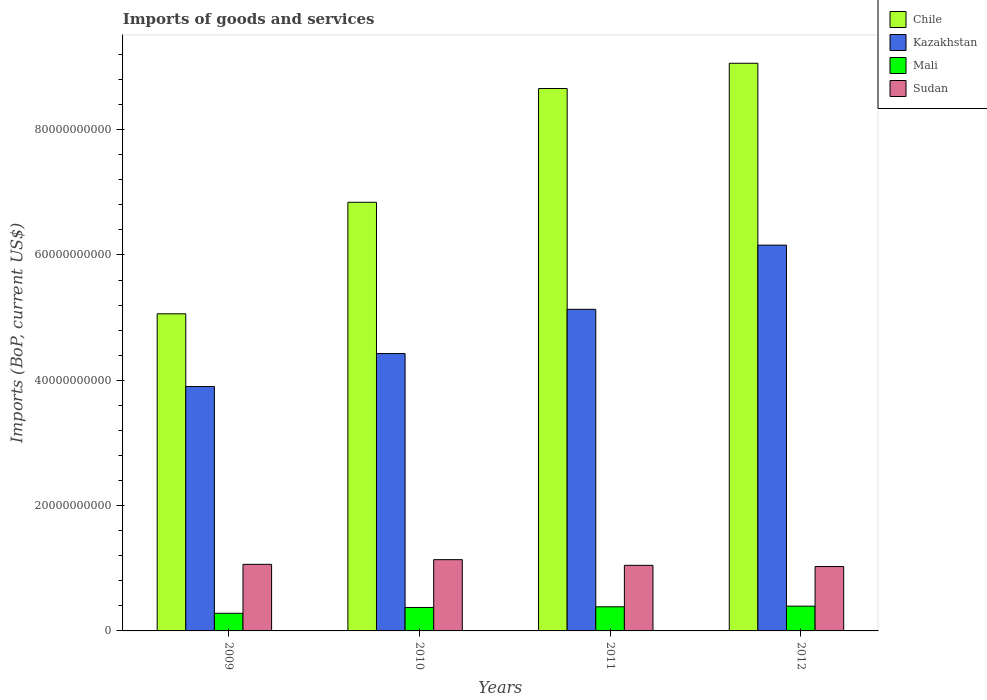How many different coloured bars are there?
Your answer should be very brief. 4. Are the number of bars on each tick of the X-axis equal?
Make the answer very short. Yes. What is the label of the 1st group of bars from the left?
Ensure brevity in your answer.  2009. In how many cases, is the number of bars for a given year not equal to the number of legend labels?
Your response must be concise. 0. What is the amount spent on imports in Chile in 2011?
Ensure brevity in your answer.  8.66e+1. Across all years, what is the maximum amount spent on imports in Mali?
Keep it short and to the point. 3.95e+09. Across all years, what is the minimum amount spent on imports in Kazakhstan?
Keep it short and to the point. 3.90e+1. In which year was the amount spent on imports in Kazakhstan maximum?
Your response must be concise. 2012. In which year was the amount spent on imports in Chile minimum?
Your answer should be very brief. 2009. What is the total amount spent on imports in Kazakhstan in the graph?
Ensure brevity in your answer.  1.96e+11. What is the difference between the amount spent on imports in Chile in 2010 and that in 2012?
Offer a terse response. -2.22e+1. What is the difference between the amount spent on imports in Sudan in 2011 and the amount spent on imports in Mali in 2009?
Keep it short and to the point. 7.65e+09. What is the average amount spent on imports in Kazakhstan per year?
Keep it short and to the point. 4.90e+1. In the year 2009, what is the difference between the amount spent on imports in Mali and amount spent on imports in Sudan?
Provide a short and direct response. -7.82e+09. What is the ratio of the amount spent on imports in Sudan in 2009 to that in 2011?
Offer a very short reply. 1.02. Is the amount spent on imports in Mali in 2010 less than that in 2012?
Provide a short and direct response. Yes. What is the difference between the highest and the second highest amount spent on imports in Chile?
Make the answer very short. 4.03e+09. What is the difference between the highest and the lowest amount spent on imports in Sudan?
Give a very brief answer. 1.10e+09. Is it the case that in every year, the sum of the amount spent on imports in Chile and amount spent on imports in Kazakhstan is greater than the sum of amount spent on imports in Sudan and amount spent on imports in Mali?
Provide a succinct answer. Yes. What does the 2nd bar from the right in 2010 represents?
Offer a terse response. Mali. How many bars are there?
Keep it short and to the point. 16. Are the values on the major ticks of Y-axis written in scientific E-notation?
Your response must be concise. No. Where does the legend appear in the graph?
Offer a terse response. Top right. What is the title of the graph?
Offer a very short reply. Imports of goods and services. Does "China" appear as one of the legend labels in the graph?
Make the answer very short. No. What is the label or title of the Y-axis?
Keep it short and to the point. Imports (BoP, current US$). What is the Imports (BoP, current US$) in Chile in 2009?
Give a very brief answer. 5.06e+1. What is the Imports (BoP, current US$) of Kazakhstan in 2009?
Provide a short and direct response. 3.90e+1. What is the Imports (BoP, current US$) of Mali in 2009?
Give a very brief answer. 2.81e+09. What is the Imports (BoP, current US$) of Sudan in 2009?
Your response must be concise. 1.06e+1. What is the Imports (BoP, current US$) in Chile in 2010?
Your answer should be very brief. 6.84e+1. What is the Imports (BoP, current US$) in Kazakhstan in 2010?
Your response must be concise. 4.43e+1. What is the Imports (BoP, current US$) of Mali in 2010?
Make the answer very short. 3.74e+09. What is the Imports (BoP, current US$) in Sudan in 2010?
Provide a succinct answer. 1.14e+1. What is the Imports (BoP, current US$) of Chile in 2011?
Your response must be concise. 8.66e+1. What is the Imports (BoP, current US$) of Kazakhstan in 2011?
Keep it short and to the point. 5.13e+1. What is the Imports (BoP, current US$) in Mali in 2011?
Keep it short and to the point. 3.85e+09. What is the Imports (BoP, current US$) of Sudan in 2011?
Your answer should be compact. 1.05e+1. What is the Imports (BoP, current US$) in Chile in 2012?
Offer a terse response. 9.06e+1. What is the Imports (BoP, current US$) of Kazakhstan in 2012?
Your response must be concise. 6.16e+1. What is the Imports (BoP, current US$) of Mali in 2012?
Give a very brief answer. 3.95e+09. What is the Imports (BoP, current US$) in Sudan in 2012?
Ensure brevity in your answer.  1.03e+1. Across all years, what is the maximum Imports (BoP, current US$) of Chile?
Give a very brief answer. 9.06e+1. Across all years, what is the maximum Imports (BoP, current US$) in Kazakhstan?
Offer a very short reply. 6.16e+1. Across all years, what is the maximum Imports (BoP, current US$) in Mali?
Provide a short and direct response. 3.95e+09. Across all years, what is the maximum Imports (BoP, current US$) in Sudan?
Make the answer very short. 1.14e+1. Across all years, what is the minimum Imports (BoP, current US$) of Chile?
Make the answer very short. 5.06e+1. Across all years, what is the minimum Imports (BoP, current US$) of Kazakhstan?
Make the answer very short. 3.90e+1. Across all years, what is the minimum Imports (BoP, current US$) in Mali?
Your answer should be compact. 2.81e+09. Across all years, what is the minimum Imports (BoP, current US$) of Sudan?
Your answer should be very brief. 1.03e+1. What is the total Imports (BoP, current US$) of Chile in the graph?
Ensure brevity in your answer.  2.96e+11. What is the total Imports (BoP, current US$) of Kazakhstan in the graph?
Your answer should be very brief. 1.96e+11. What is the total Imports (BoP, current US$) of Mali in the graph?
Offer a very short reply. 1.44e+1. What is the total Imports (BoP, current US$) in Sudan in the graph?
Give a very brief answer. 4.27e+1. What is the difference between the Imports (BoP, current US$) in Chile in 2009 and that in 2010?
Provide a succinct answer. -1.78e+1. What is the difference between the Imports (BoP, current US$) in Kazakhstan in 2009 and that in 2010?
Your answer should be very brief. -5.26e+09. What is the difference between the Imports (BoP, current US$) in Mali in 2009 and that in 2010?
Your answer should be very brief. -9.33e+08. What is the difference between the Imports (BoP, current US$) in Sudan in 2009 and that in 2010?
Offer a terse response. -7.43e+08. What is the difference between the Imports (BoP, current US$) in Chile in 2009 and that in 2011?
Offer a terse response. -3.60e+1. What is the difference between the Imports (BoP, current US$) in Kazakhstan in 2009 and that in 2011?
Offer a terse response. -1.23e+1. What is the difference between the Imports (BoP, current US$) of Mali in 2009 and that in 2011?
Make the answer very short. -1.04e+09. What is the difference between the Imports (BoP, current US$) in Sudan in 2009 and that in 2011?
Provide a succinct answer. 1.64e+08. What is the difference between the Imports (BoP, current US$) in Chile in 2009 and that in 2012?
Provide a succinct answer. -4.00e+1. What is the difference between the Imports (BoP, current US$) in Kazakhstan in 2009 and that in 2012?
Offer a terse response. -2.26e+1. What is the difference between the Imports (BoP, current US$) in Mali in 2009 and that in 2012?
Provide a succinct answer. -1.14e+09. What is the difference between the Imports (BoP, current US$) in Sudan in 2009 and that in 2012?
Make the answer very short. 3.55e+08. What is the difference between the Imports (BoP, current US$) of Chile in 2010 and that in 2011?
Your response must be concise. -1.82e+1. What is the difference between the Imports (BoP, current US$) of Kazakhstan in 2010 and that in 2011?
Provide a short and direct response. -7.06e+09. What is the difference between the Imports (BoP, current US$) of Mali in 2010 and that in 2011?
Keep it short and to the point. -1.06e+08. What is the difference between the Imports (BoP, current US$) in Sudan in 2010 and that in 2011?
Keep it short and to the point. 9.07e+08. What is the difference between the Imports (BoP, current US$) in Chile in 2010 and that in 2012?
Offer a very short reply. -2.22e+1. What is the difference between the Imports (BoP, current US$) in Kazakhstan in 2010 and that in 2012?
Provide a succinct answer. -1.73e+1. What is the difference between the Imports (BoP, current US$) of Mali in 2010 and that in 2012?
Offer a terse response. -2.09e+08. What is the difference between the Imports (BoP, current US$) of Sudan in 2010 and that in 2012?
Keep it short and to the point. 1.10e+09. What is the difference between the Imports (BoP, current US$) of Chile in 2011 and that in 2012?
Give a very brief answer. -4.03e+09. What is the difference between the Imports (BoP, current US$) in Kazakhstan in 2011 and that in 2012?
Make the answer very short. -1.02e+1. What is the difference between the Imports (BoP, current US$) of Mali in 2011 and that in 2012?
Keep it short and to the point. -1.03e+08. What is the difference between the Imports (BoP, current US$) of Sudan in 2011 and that in 2012?
Provide a succinct answer. 1.92e+08. What is the difference between the Imports (BoP, current US$) in Chile in 2009 and the Imports (BoP, current US$) in Kazakhstan in 2010?
Provide a short and direct response. 6.35e+09. What is the difference between the Imports (BoP, current US$) in Chile in 2009 and the Imports (BoP, current US$) in Mali in 2010?
Your answer should be compact. 4.69e+1. What is the difference between the Imports (BoP, current US$) of Chile in 2009 and the Imports (BoP, current US$) of Sudan in 2010?
Keep it short and to the point. 3.92e+1. What is the difference between the Imports (BoP, current US$) in Kazakhstan in 2009 and the Imports (BoP, current US$) in Mali in 2010?
Make the answer very short. 3.53e+1. What is the difference between the Imports (BoP, current US$) of Kazakhstan in 2009 and the Imports (BoP, current US$) of Sudan in 2010?
Your answer should be compact. 2.76e+1. What is the difference between the Imports (BoP, current US$) in Mali in 2009 and the Imports (BoP, current US$) in Sudan in 2010?
Offer a terse response. -8.56e+09. What is the difference between the Imports (BoP, current US$) in Chile in 2009 and the Imports (BoP, current US$) in Kazakhstan in 2011?
Keep it short and to the point. -7.17e+08. What is the difference between the Imports (BoP, current US$) of Chile in 2009 and the Imports (BoP, current US$) of Mali in 2011?
Keep it short and to the point. 4.68e+1. What is the difference between the Imports (BoP, current US$) in Chile in 2009 and the Imports (BoP, current US$) in Sudan in 2011?
Your response must be concise. 4.01e+1. What is the difference between the Imports (BoP, current US$) of Kazakhstan in 2009 and the Imports (BoP, current US$) of Mali in 2011?
Provide a short and direct response. 3.52e+1. What is the difference between the Imports (BoP, current US$) in Kazakhstan in 2009 and the Imports (BoP, current US$) in Sudan in 2011?
Make the answer very short. 2.85e+1. What is the difference between the Imports (BoP, current US$) in Mali in 2009 and the Imports (BoP, current US$) in Sudan in 2011?
Make the answer very short. -7.65e+09. What is the difference between the Imports (BoP, current US$) in Chile in 2009 and the Imports (BoP, current US$) in Kazakhstan in 2012?
Make the answer very short. -1.10e+1. What is the difference between the Imports (BoP, current US$) in Chile in 2009 and the Imports (BoP, current US$) in Mali in 2012?
Provide a short and direct response. 4.67e+1. What is the difference between the Imports (BoP, current US$) of Chile in 2009 and the Imports (BoP, current US$) of Sudan in 2012?
Give a very brief answer. 4.03e+1. What is the difference between the Imports (BoP, current US$) in Kazakhstan in 2009 and the Imports (BoP, current US$) in Mali in 2012?
Offer a terse response. 3.50e+1. What is the difference between the Imports (BoP, current US$) of Kazakhstan in 2009 and the Imports (BoP, current US$) of Sudan in 2012?
Keep it short and to the point. 2.87e+1. What is the difference between the Imports (BoP, current US$) in Mali in 2009 and the Imports (BoP, current US$) in Sudan in 2012?
Your answer should be very brief. -7.46e+09. What is the difference between the Imports (BoP, current US$) of Chile in 2010 and the Imports (BoP, current US$) of Kazakhstan in 2011?
Provide a short and direct response. 1.71e+1. What is the difference between the Imports (BoP, current US$) of Chile in 2010 and the Imports (BoP, current US$) of Mali in 2011?
Offer a very short reply. 6.45e+1. What is the difference between the Imports (BoP, current US$) of Chile in 2010 and the Imports (BoP, current US$) of Sudan in 2011?
Your answer should be very brief. 5.79e+1. What is the difference between the Imports (BoP, current US$) of Kazakhstan in 2010 and the Imports (BoP, current US$) of Mali in 2011?
Offer a terse response. 4.04e+1. What is the difference between the Imports (BoP, current US$) of Kazakhstan in 2010 and the Imports (BoP, current US$) of Sudan in 2011?
Offer a very short reply. 3.38e+1. What is the difference between the Imports (BoP, current US$) of Mali in 2010 and the Imports (BoP, current US$) of Sudan in 2011?
Provide a short and direct response. -6.72e+09. What is the difference between the Imports (BoP, current US$) of Chile in 2010 and the Imports (BoP, current US$) of Kazakhstan in 2012?
Keep it short and to the point. 6.84e+09. What is the difference between the Imports (BoP, current US$) in Chile in 2010 and the Imports (BoP, current US$) in Mali in 2012?
Provide a succinct answer. 6.44e+1. What is the difference between the Imports (BoP, current US$) of Chile in 2010 and the Imports (BoP, current US$) of Sudan in 2012?
Offer a terse response. 5.81e+1. What is the difference between the Imports (BoP, current US$) of Kazakhstan in 2010 and the Imports (BoP, current US$) of Mali in 2012?
Offer a terse response. 4.03e+1. What is the difference between the Imports (BoP, current US$) of Kazakhstan in 2010 and the Imports (BoP, current US$) of Sudan in 2012?
Make the answer very short. 3.40e+1. What is the difference between the Imports (BoP, current US$) in Mali in 2010 and the Imports (BoP, current US$) in Sudan in 2012?
Offer a terse response. -6.53e+09. What is the difference between the Imports (BoP, current US$) of Chile in 2011 and the Imports (BoP, current US$) of Kazakhstan in 2012?
Provide a short and direct response. 2.50e+1. What is the difference between the Imports (BoP, current US$) in Chile in 2011 and the Imports (BoP, current US$) in Mali in 2012?
Make the answer very short. 8.26e+1. What is the difference between the Imports (BoP, current US$) of Chile in 2011 and the Imports (BoP, current US$) of Sudan in 2012?
Provide a short and direct response. 7.63e+1. What is the difference between the Imports (BoP, current US$) in Kazakhstan in 2011 and the Imports (BoP, current US$) in Mali in 2012?
Offer a terse response. 4.74e+1. What is the difference between the Imports (BoP, current US$) of Kazakhstan in 2011 and the Imports (BoP, current US$) of Sudan in 2012?
Offer a terse response. 4.10e+1. What is the difference between the Imports (BoP, current US$) of Mali in 2011 and the Imports (BoP, current US$) of Sudan in 2012?
Give a very brief answer. -6.42e+09. What is the average Imports (BoP, current US$) in Chile per year?
Offer a very short reply. 7.40e+1. What is the average Imports (BoP, current US$) of Kazakhstan per year?
Offer a very short reply. 4.90e+1. What is the average Imports (BoP, current US$) in Mali per year?
Offer a terse response. 3.59e+09. What is the average Imports (BoP, current US$) of Sudan per year?
Provide a succinct answer. 1.07e+1. In the year 2009, what is the difference between the Imports (BoP, current US$) in Chile and Imports (BoP, current US$) in Kazakhstan?
Your response must be concise. 1.16e+1. In the year 2009, what is the difference between the Imports (BoP, current US$) of Chile and Imports (BoP, current US$) of Mali?
Your answer should be compact. 4.78e+1. In the year 2009, what is the difference between the Imports (BoP, current US$) of Chile and Imports (BoP, current US$) of Sudan?
Keep it short and to the point. 4.00e+1. In the year 2009, what is the difference between the Imports (BoP, current US$) of Kazakhstan and Imports (BoP, current US$) of Mali?
Make the answer very short. 3.62e+1. In the year 2009, what is the difference between the Imports (BoP, current US$) of Kazakhstan and Imports (BoP, current US$) of Sudan?
Keep it short and to the point. 2.84e+1. In the year 2009, what is the difference between the Imports (BoP, current US$) of Mali and Imports (BoP, current US$) of Sudan?
Keep it short and to the point. -7.82e+09. In the year 2010, what is the difference between the Imports (BoP, current US$) in Chile and Imports (BoP, current US$) in Kazakhstan?
Ensure brevity in your answer.  2.41e+1. In the year 2010, what is the difference between the Imports (BoP, current US$) in Chile and Imports (BoP, current US$) in Mali?
Offer a very short reply. 6.47e+1. In the year 2010, what is the difference between the Imports (BoP, current US$) in Chile and Imports (BoP, current US$) in Sudan?
Give a very brief answer. 5.70e+1. In the year 2010, what is the difference between the Imports (BoP, current US$) of Kazakhstan and Imports (BoP, current US$) of Mali?
Your answer should be very brief. 4.05e+1. In the year 2010, what is the difference between the Imports (BoP, current US$) in Kazakhstan and Imports (BoP, current US$) in Sudan?
Your answer should be compact. 3.29e+1. In the year 2010, what is the difference between the Imports (BoP, current US$) in Mali and Imports (BoP, current US$) in Sudan?
Keep it short and to the point. -7.63e+09. In the year 2011, what is the difference between the Imports (BoP, current US$) of Chile and Imports (BoP, current US$) of Kazakhstan?
Offer a very short reply. 3.52e+1. In the year 2011, what is the difference between the Imports (BoP, current US$) in Chile and Imports (BoP, current US$) in Mali?
Keep it short and to the point. 8.27e+1. In the year 2011, what is the difference between the Imports (BoP, current US$) in Chile and Imports (BoP, current US$) in Sudan?
Make the answer very short. 7.61e+1. In the year 2011, what is the difference between the Imports (BoP, current US$) in Kazakhstan and Imports (BoP, current US$) in Mali?
Make the answer very short. 4.75e+1. In the year 2011, what is the difference between the Imports (BoP, current US$) of Kazakhstan and Imports (BoP, current US$) of Sudan?
Provide a succinct answer. 4.09e+1. In the year 2011, what is the difference between the Imports (BoP, current US$) in Mali and Imports (BoP, current US$) in Sudan?
Offer a terse response. -6.61e+09. In the year 2012, what is the difference between the Imports (BoP, current US$) in Chile and Imports (BoP, current US$) in Kazakhstan?
Offer a very short reply. 2.90e+1. In the year 2012, what is the difference between the Imports (BoP, current US$) of Chile and Imports (BoP, current US$) of Mali?
Keep it short and to the point. 8.66e+1. In the year 2012, what is the difference between the Imports (BoP, current US$) of Chile and Imports (BoP, current US$) of Sudan?
Offer a very short reply. 8.03e+1. In the year 2012, what is the difference between the Imports (BoP, current US$) of Kazakhstan and Imports (BoP, current US$) of Mali?
Ensure brevity in your answer.  5.76e+1. In the year 2012, what is the difference between the Imports (BoP, current US$) in Kazakhstan and Imports (BoP, current US$) in Sudan?
Ensure brevity in your answer.  5.13e+1. In the year 2012, what is the difference between the Imports (BoP, current US$) in Mali and Imports (BoP, current US$) in Sudan?
Offer a very short reply. -6.32e+09. What is the ratio of the Imports (BoP, current US$) of Chile in 2009 to that in 2010?
Provide a short and direct response. 0.74. What is the ratio of the Imports (BoP, current US$) in Kazakhstan in 2009 to that in 2010?
Your answer should be compact. 0.88. What is the ratio of the Imports (BoP, current US$) in Mali in 2009 to that in 2010?
Your answer should be compact. 0.75. What is the ratio of the Imports (BoP, current US$) in Sudan in 2009 to that in 2010?
Provide a short and direct response. 0.93. What is the ratio of the Imports (BoP, current US$) in Chile in 2009 to that in 2011?
Ensure brevity in your answer.  0.58. What is the ratio of the Imports (BoP, current US$) in Kazakhstan in 2009 to that in 2011?
Give a very brief answer. 0.76. What is the ratio of the Imports (BoP, current US$) of Mali in 2009 to that in 2011?
Ensure brevity in your answer.  0.73. What is the ratio of the Imports (BoP, current US$) in Sudan in 2009 to that in 2011?
Ensure brevity in your answer.  1.02. What is the ratio of the Imports (BoP, current US$) in Chile in 2009 to that in 2012?
Your response must be concise. 0.56. What is the ratio of the Imports (BoP, current US$) of Kazakhstan in 2009 to that in 2012?
Provide a short and direct response. 0.63. What is the ratio of the Imports (BoP, current US$) of Mali in 2009 to that in 2012?
Offer a terse response. 0.71. What is the ratio of the Imports (BoP, current US$) of Sudan in 2009 to that in 2012?
Offer a very short reply. 1.03. What is the ratio of the Imports (BoP, current US$) in Chile in 2010 to that in 2011?
Your answer should be very brief. 0.79. What is the ratio of the Imports (BoP, current US$) of Kazakhstan in 2010 to that in 2011?
Your response must be concise. 0.86. What is the ratio of the Imports (BoP, current US$) in Mali in 2010 to that in 2011?
Your response must be concise. 0.97. What is the ratio of the Imports (BoP, current US$) in Sudan in 2010 to that in 2011?
Make the answer very short. 1.09. What is the ratio of the Imports (BoP, current US$) in Chile in 2010 to that in 2012?
Provide a short and direct response. 0.76. What is the ratio of the Imports (BoP, current US$) of Kazakhstan in 2010 to that in 2012?
Make the answer very short. 0.72. What is the ratio of the Imports (BoP, current US$) in Mali in 2010 to that in 2012?
Provide a succinct answer. 0.95. What is the ratio of the Imports (BoP, current US$) in Sudan in 2010 to that in 2012?
Provide a succinct answer. 1.11. What is the ratio of the Imports (BoP, current US$) in Chile in 2011 to that in 2012?
Your answer should be very brief. 0.96. What is the ratio of the Imports (BoP, current US$) of Kazakhstan in 2011 to that in 2012?
Provide a succinct answer. 0.83. What is the ratio of the Imports (BoP, current US$) in Mali in 2011 to that in 2012?
Offer a very short reply. 0.97. What is the ratio of the Imports (BoP, current US$) in Sudan in 2011 to that in 2012?
Your response must be concise. 1.02. What is the difference between the highest and the second highest Imports (BoP, current US$) in Chile?
Ensure brevity in your answer.  4.03e+09. What is the difference between the highest and the second highest Imports (BoP, current US$) of Kazakhstan?
Make the answer very short. 1.02e+1. What is the difference between the highest and the second highest Imports (BoP, current US$) of Mali?
Provide a succinct answer. 1.03e+08. What is the difference between the highest and the second highest Imports (BoP, current US$) in Sudan?
Keep it short and to the point. 7.43e+08. What is the difference between the highest and the lowest Imports (BoP, current US$) in Chile?
Keep it short and to the point. 4.00e+1. What is the difference between the highest and the lowest Imports (BoP, current US$) in Kazakhstan?
Your answer should be compact. 2.26e+1. What is the difference between the highest and the lowest Imports (BoP, current US$) in Mali?
Provide a short and direct response. 1.14e+09. What is the difference between the highest and the lowest Imports (BoP, current US$) of Sudan?
Your answer should be very brief. 1.10e+09. 